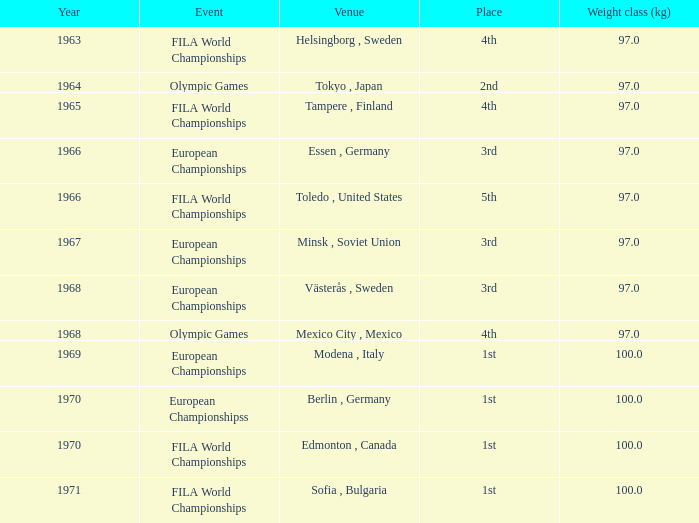What is the peak year for fila world championships as the contest, hosted in toledo, united states, and including a weight group (kg) lesser than 97? None. 